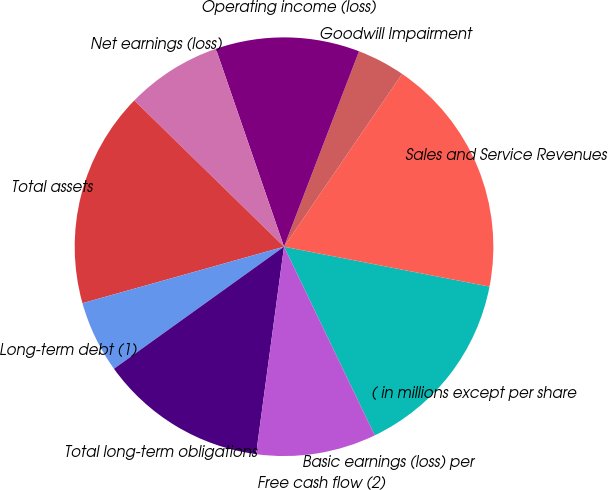Convert chart. <chart><loc_0><loc_0><loc_500><loc_500><pie_chart><fcel>( in millions except per share<fcel>Sales and Service Revenues<fcel>Goodwill Impairment<fcel>Operating income (loss)<fcel>Net earnings (loss)<fcel>Total assets<fcel>Long-term debt (1)<fcel>Total long-term obligations<fcel>Free cash flow (2)<fcel>Basic earnings (loss) per<nl><fcel>14.81%<fcel>18.51%<fcel>3.71%<fcel>11.11%<fcel>7.41%<fcel>16.66%<fcel>5.56%<fcel>12.96%<fcel>9.26%<fcel>0.01%<nl></chart> 